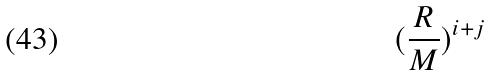<formula> <loc_0><loc_0><loc_500><loc_500>( \frac { R } { M } ) ^ { i + j }</formula> 